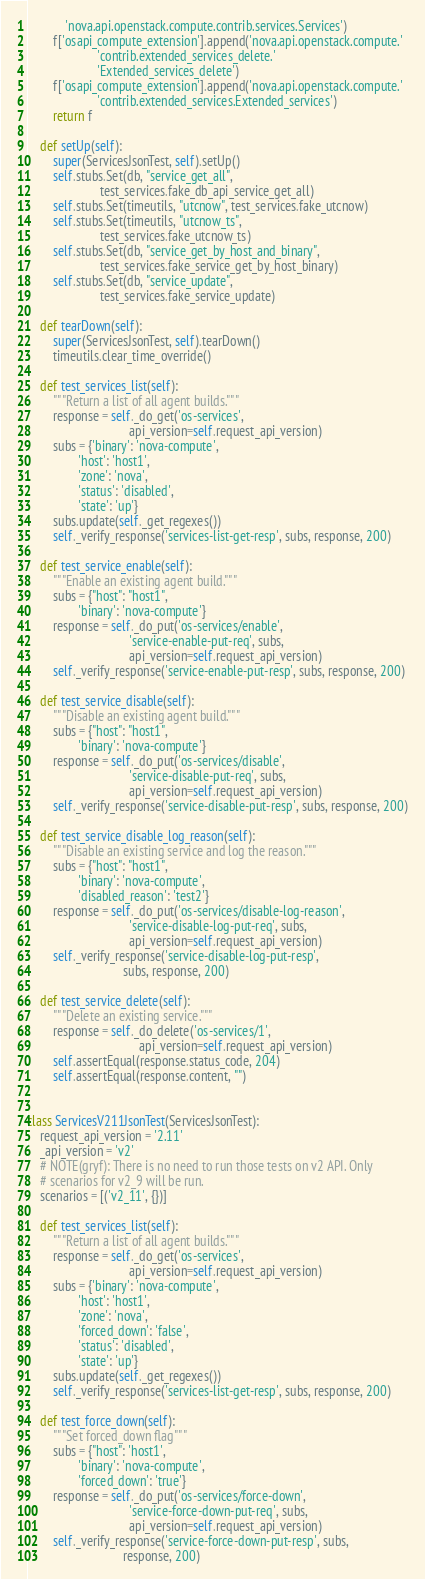<code> <loc_0><loc_0><loc_500><loc_500><_Python_>            'nova.api.openstack.compute.contrib.services.Services')
        f['osapi_compute_extension'].append('nova.api.openstack.compute.'
                      'contrib.extended_services_delete.'
                      'Extended_services_delete')
        f['osapi_compute_extension'].append('nova.api.openstack.compute.'
                      'contrib.extended_services.Extended_services')
        return f

    def setUp(self):
        super(ServicesJsonTest, self).setUp()
        self.stubs.Set(db, "service_get_all",
                       test_services.fake_db_api_service_get_all)
        self.stubs.Set(timeutils, "utcnow", test_services.fake_utcnow)
        self.stubs.Set(timeutils, "utcnow_ts",
                       test_services.fake_utcnow_ts)
        self.stubs.Set(db, "service_get_by_host_and_binary",
                       test_services.fake_service_get_by_host_binary)
        self.stubs.Set(db, "service_update",
                       test_services.fake_service_update)

    def tearDown(self):
        super(ServicesJsonTest, self).tearDown()
        timeutils.clear_time_override()

    def test_services_list(self):
        """Return a list of all agent builds."""
        response = self._do_get('os-services',
                                api_version=self.request_api_version)
        subs = {'binary': 'nova-compute',
                'host': 'host1',
                'zone': 'nova',
                'status': 'disabled',
                'state': 'up'}
        subs.update(self._get_regexes())
        self._verify_response('services-list-get-resp', subs, response, 200)

    def test_service_enable(self):
        """Enable an existing agent build."""
        subs = {"host": "host1",
                'binary': 'nova-compute'}
        response = self._do_put('os-services/enable',
                                'service-enable-put-req', subs,
                                api_version=self.request_api_version)
        self._verify_response('service-enable-put-resp', subs, response, 200)

    def test_service_disable(self):
        """Disable an existing agent build."""
        subs = {"host": "host1",
                'binary': 'nova-compute'}
        response = self._do_put('os-services/disable',
                                'service-disable-put-req', subs,
                                api_version=self.request_api_version)
        self._verify_response('service-disable-put-resp', subs, response, 200)

    def test_service_disable_log_reason(self):
        """Disable an existing service and log the reason."""
        subs = {"host": "host1",
                'binary': 'nova-compute',
                'disabled_reason': 'test2'}
        response = self._do_put('os-services/disable-log-reason',
                                'service-disable-log-put-req', subs,
                                api_version=self.request_api_version)
        self._verify_response('service-disable-log-put-resp',
                              subs, response, 200)

    def test_service_delete(self):
        """Delete an existing service."""
        response = self._do_delete('os-services/1',
                                   api_version=self.request_api_version)
        self.assertEqual(response.status_code, 204)
        self.assertEqual(response.content, "")


class ServicesV211JsonTest(ServicesJsonTest):
    request_api_version = '2.11'
    _api_version = 'v2'
    # NOTE(gryf): There is no need to run those tests on v2 API. Only
    # scenarios for v2_9 will be run.
    scenarios = [('v2_11', {})]

    def test_services_list(self):
        """Return a list of all agent builds."""
        response = self._do_get('os-services',
                                api_version=self.request_api_version)
        subs = {'binary': 'nova-compute',
                'host': 'host1',
                'zone': 'nova',
                'forced_down': 'false',
                'status': 'disabled',
                'state': 'up'}
        subs.update(self._get_regexes())
        self._verify_response('services-list-get-resp', subs, response, 200)

    def test_force_down(self):
        """Set forced_down flag"""
        subs = {"host": 'host1',
                'binary': 'nova-compute',
                'forced_down': 'true'}
        response = self._do_put('os-services/force-down',
                                'service-force-down-put-req', subs,
                                api_version=self.request_api_version)
        self._verify_response('service-force-down-put-resp', subs,
                              response, 200)
</code> 